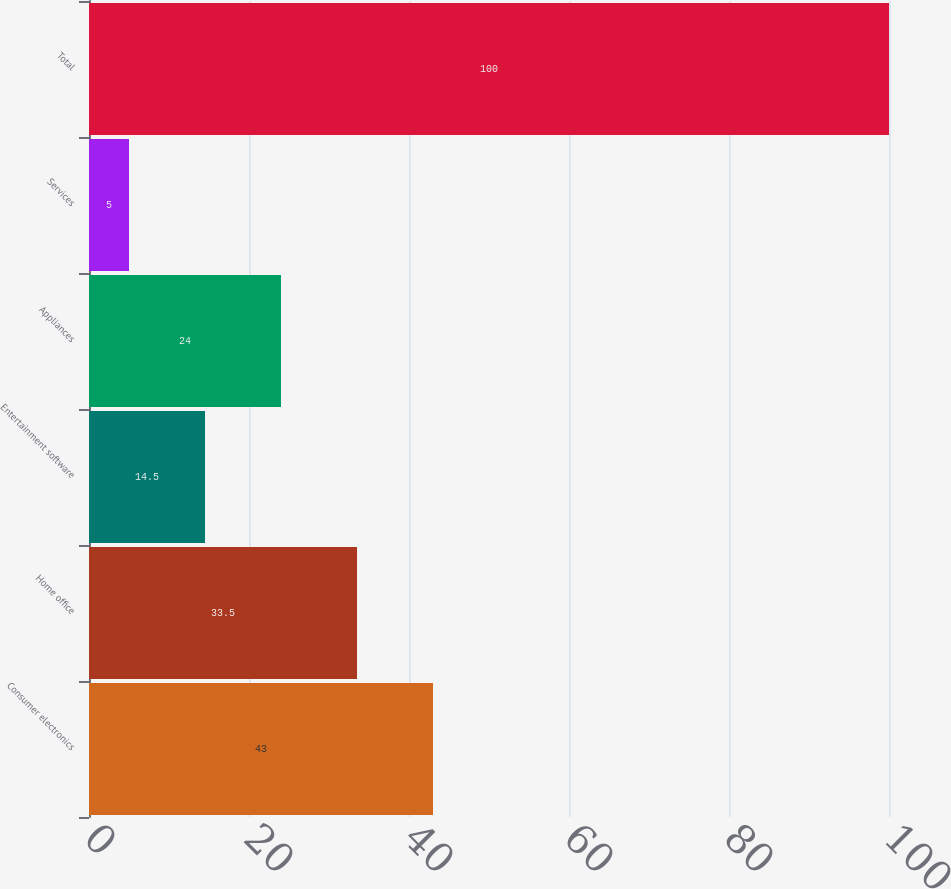<chart> <loc_0><loc_0><loc_500><loc_500><bar_chart><fcel>Consumer electronics<fcel>Home office<fcel>Entertainment software<fcel>Appliances<fcel>Services<fcel>Total<nl><fcel>43<fcel>33.5<fcel>14.5<fcel>24<fcel>5<fcel>100<nl></chart> 